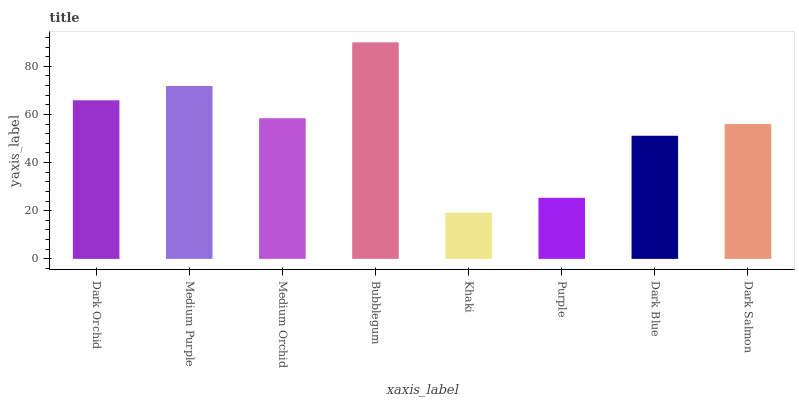Is Khaki the minimum?
Answer yes or no. Yes. Is Bubblegum the maximum?
Answer yes or no. Yes. Is Medium Purple the minimum?
Answer yes or no. No. Is Medium Purple the maximum?
Answer yes or no. No. Is Medium Purple greater than Dark Orchid?
Answer yes or no. Yes. Is Dark Orchid less than Medium Purple?
Answer yes or no. Yes. Is Dark Orchid greater than Medium Purple?
Answer yes or no. No. Is Medium Purple less than Dark Orchid?
Answer yes or no. No. Is Medium Orchid the high median?
Answer yes or no. Yes. Is Dark Salmon the low median?
Answer yes or no. Yes. Is Bubblegum the high median?
Answer yes or no. No. Is Purple the low median?
Answer yes or no. No. 